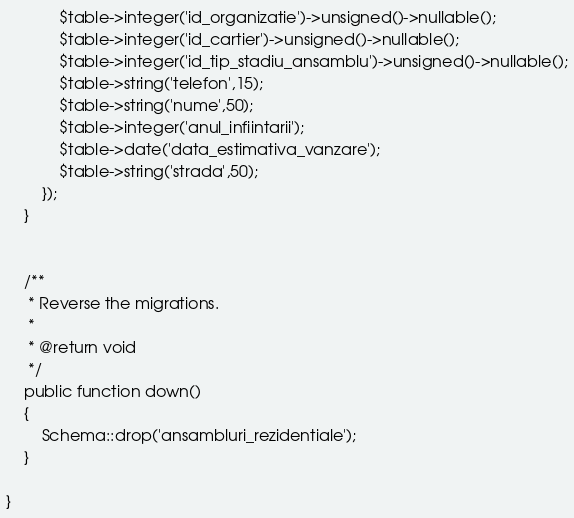<code> <loc_0><loc_0><loc_500><loc_500><_PHP_>			$table->integer('id_organizatie')->unsigned()->nullable();
			$table->integer('id_cartier')->unsigned()->nullable();
			$table->integer('id_tip_stadiu_ansamblu')->unsigned()->nullable();
			$table->string('telefon',15);
			$table->string('nume',50);
			$table->integer('anul_infiintarii');
			$table->date('data_estimativa_vanzare');
			$table->string('strada',50);
		});
	}


	/**
	 * Reverse the migrations.
	 *
	 * @return void
	 */
	public function down()
	{
		Schema::drop('ansambluri_rezidentiale');
	}

}
</code> 